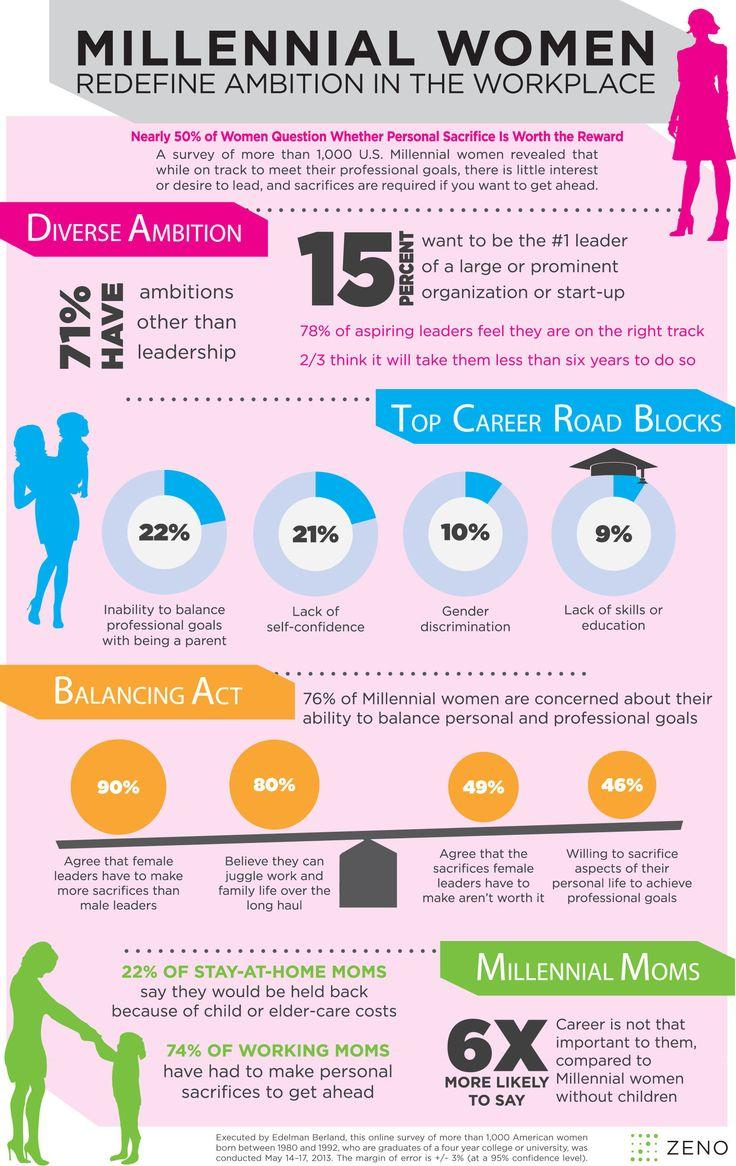List a handful of essential elements in this visual. According to the survey, 49% of respondents believe that the sacrifices female leaders make are not worth it. In a survey of women, 21% reported lack of self-confidence as their top career roadblock. According to the survey, 90% of respondents believe that female leaders have to make more sacrifices than male leaders. Gender discrimination and a lack of skills or education are the two primary reasons for career road blocks. Six out of every ten millennial moms believe that career is not as important as other aspects of life for millennial women without children. 